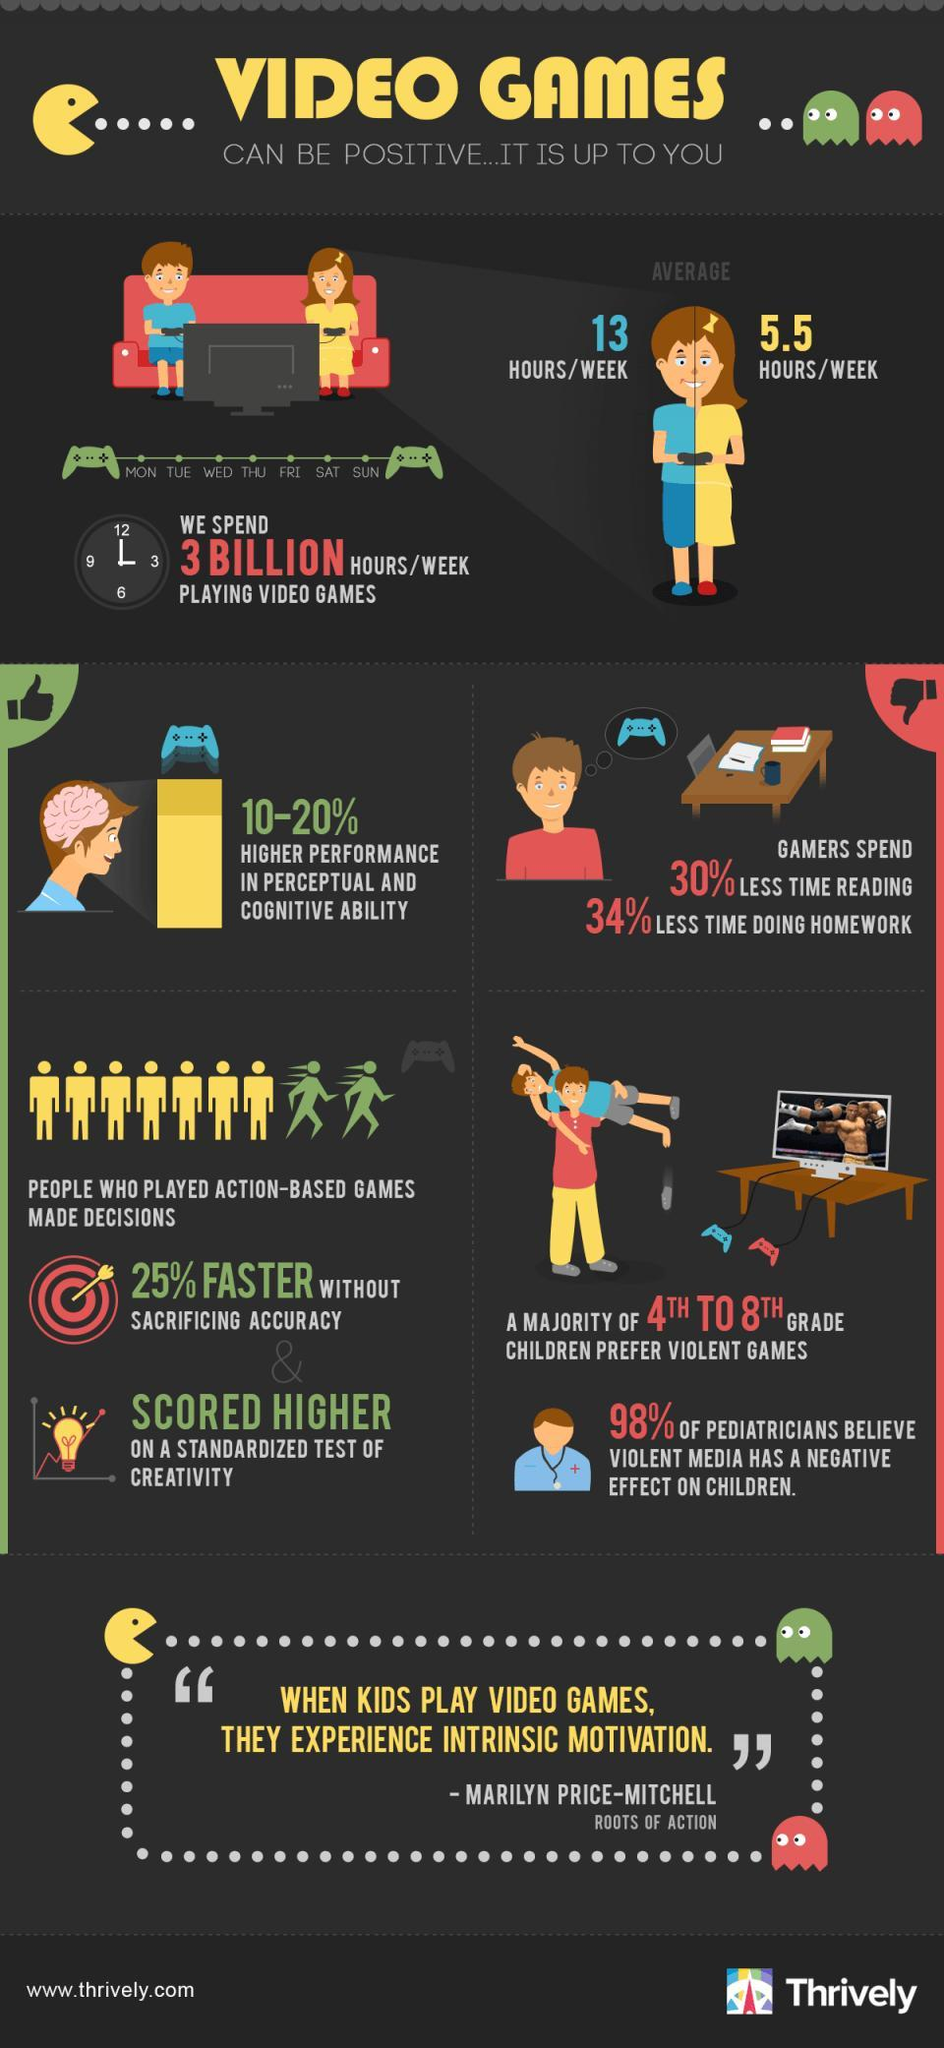What is the average time spent on video games by girls?
Answer the question with a short phrase. 5.5 hours/week In what two tasks do gamers spend less time? reading, doing homework What according to pediatricians has an adverse impact on children? violent media In what did gamers show 10-20% higher performance? perceptual and cognitive ability What is the average time spent on video games by boys? 13 hours/week Who were able to score better in standardized creativity tests? people who played action-based games 